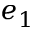<formula> <loc_0><loc_0><loc_500><loc_500>e _ { 1 }</formula> 